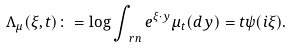Convert formula to latex. <formula><loc_0><loc_0><loc_500><loc_500>\Lambda _ { \mu } ( \xi , t ) \colon = \log \int _ { \ r n } e ^ { \xi \cdot y } \mu _ { t } ( d y ) = t \psi ( i \xi ) .</formula> 